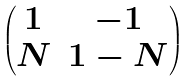Convert formula to latex. <formula><loc_0><loc_0><loc_500><loc_500>\begin{pmatrix} 1 & - 1 \\ N & 1 - N \end{pmatrix}</formula> 